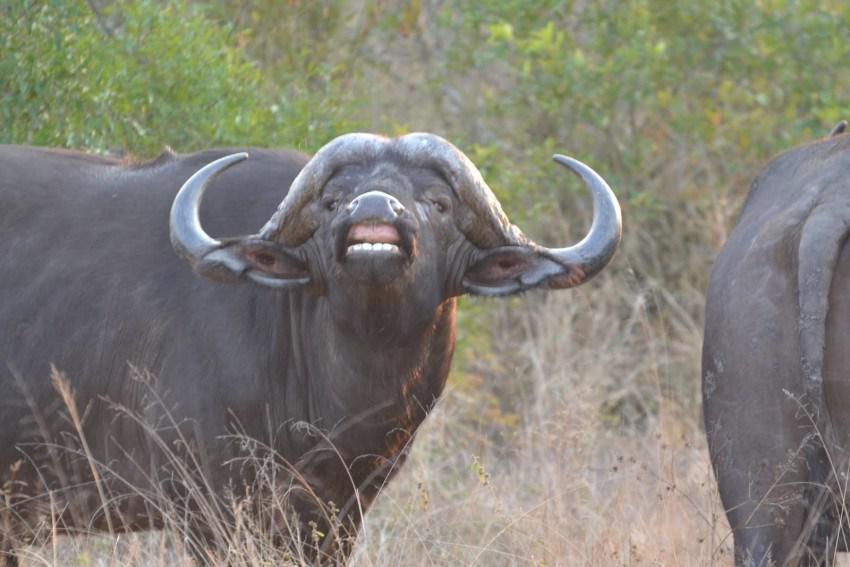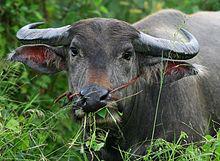The first image is the image on the left, the second image is the image on the right. Analyze the images presented: Is the assertion "Every animal has horns and none has a bird on its head." valid? Answer yes or no. Yes. 